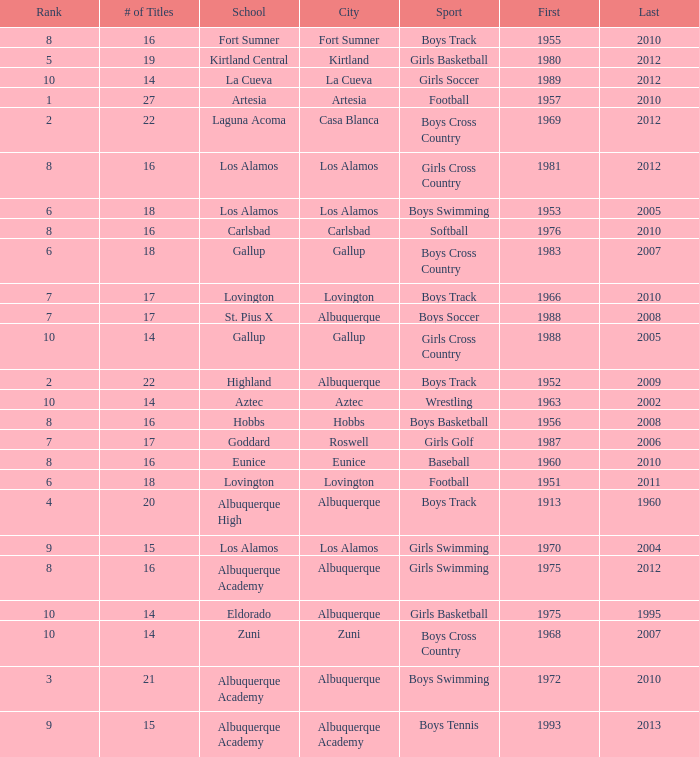What is the total rank number for Los Alamos' girls cross country? 1.0. 